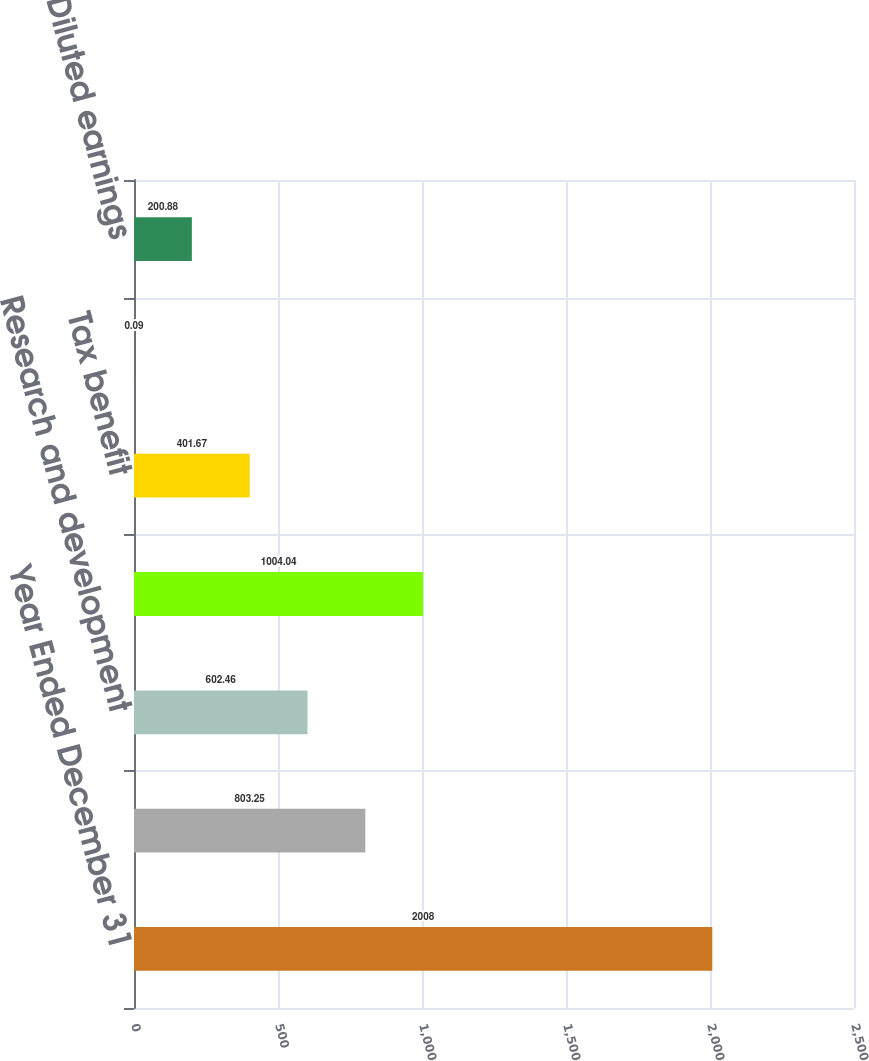Convert chart to OTSL. <chart><loc_0><loc_0><loc_500><loc_500><bar_chart><fcel>Year Ended December 31<fcel>Selling general and<fcel>Research and development<fcel>Share-based compensation<fcel>Tax benefit<fcel>Decrease in Basic earnings per<fcel>Decrease in Diluted earnings<nl><fcel>2008<fcel>803.25<fcel>602.46<fcel>1004.04<fcel>401.67<fcel>0.09<fcel>200.88<nl></chart> 